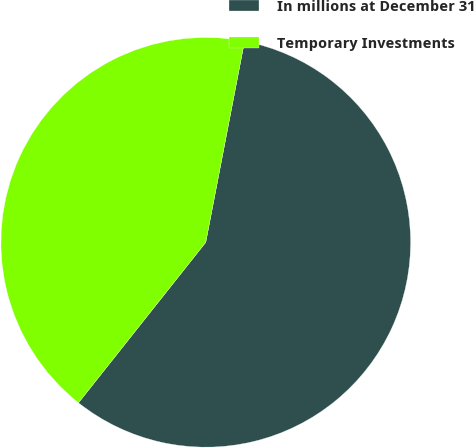Convert chart. <chart><loc_0><loc_0><loc_500><loc_500><pie_chart><fcel>In millions at December 31<fcel>Temporary Investments<nl><fcel>57.64%<fcel>42.36%<nl></chart> 